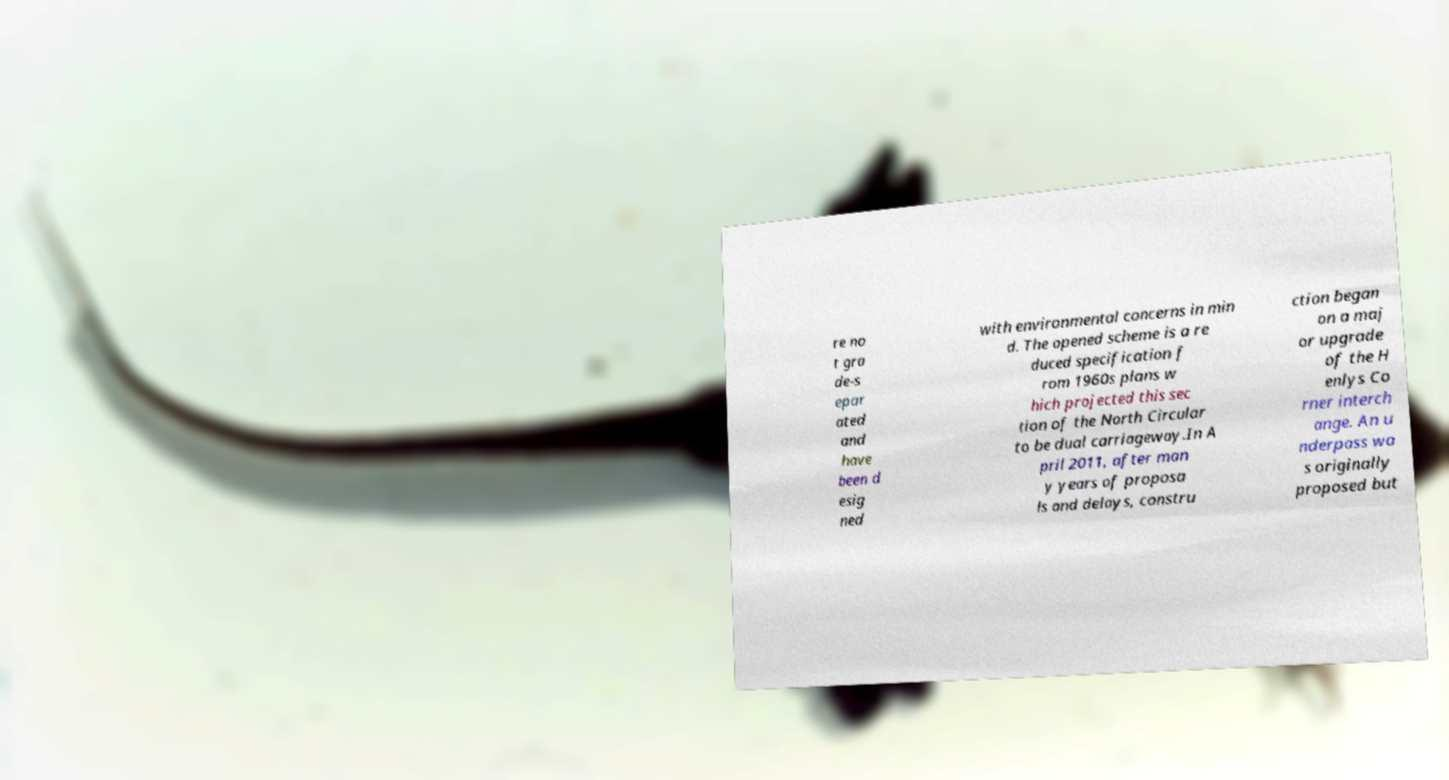For documentation purposes, I need the text within this image transcribed. Could you provide that? re no t gra de-s epar ated and have been d esig ned with environmental concerns in min d. The opened scheme is a re duced specification f rom 1960s plans w hich projected this sec tion of the North Circular to be dual carriageway.In A pril 2011, after man y years of proposa ls and delays, constru ction began on a maj or upgrade of the H enlys Co rner interch ange. An u nderpass wa s originally proposed but 